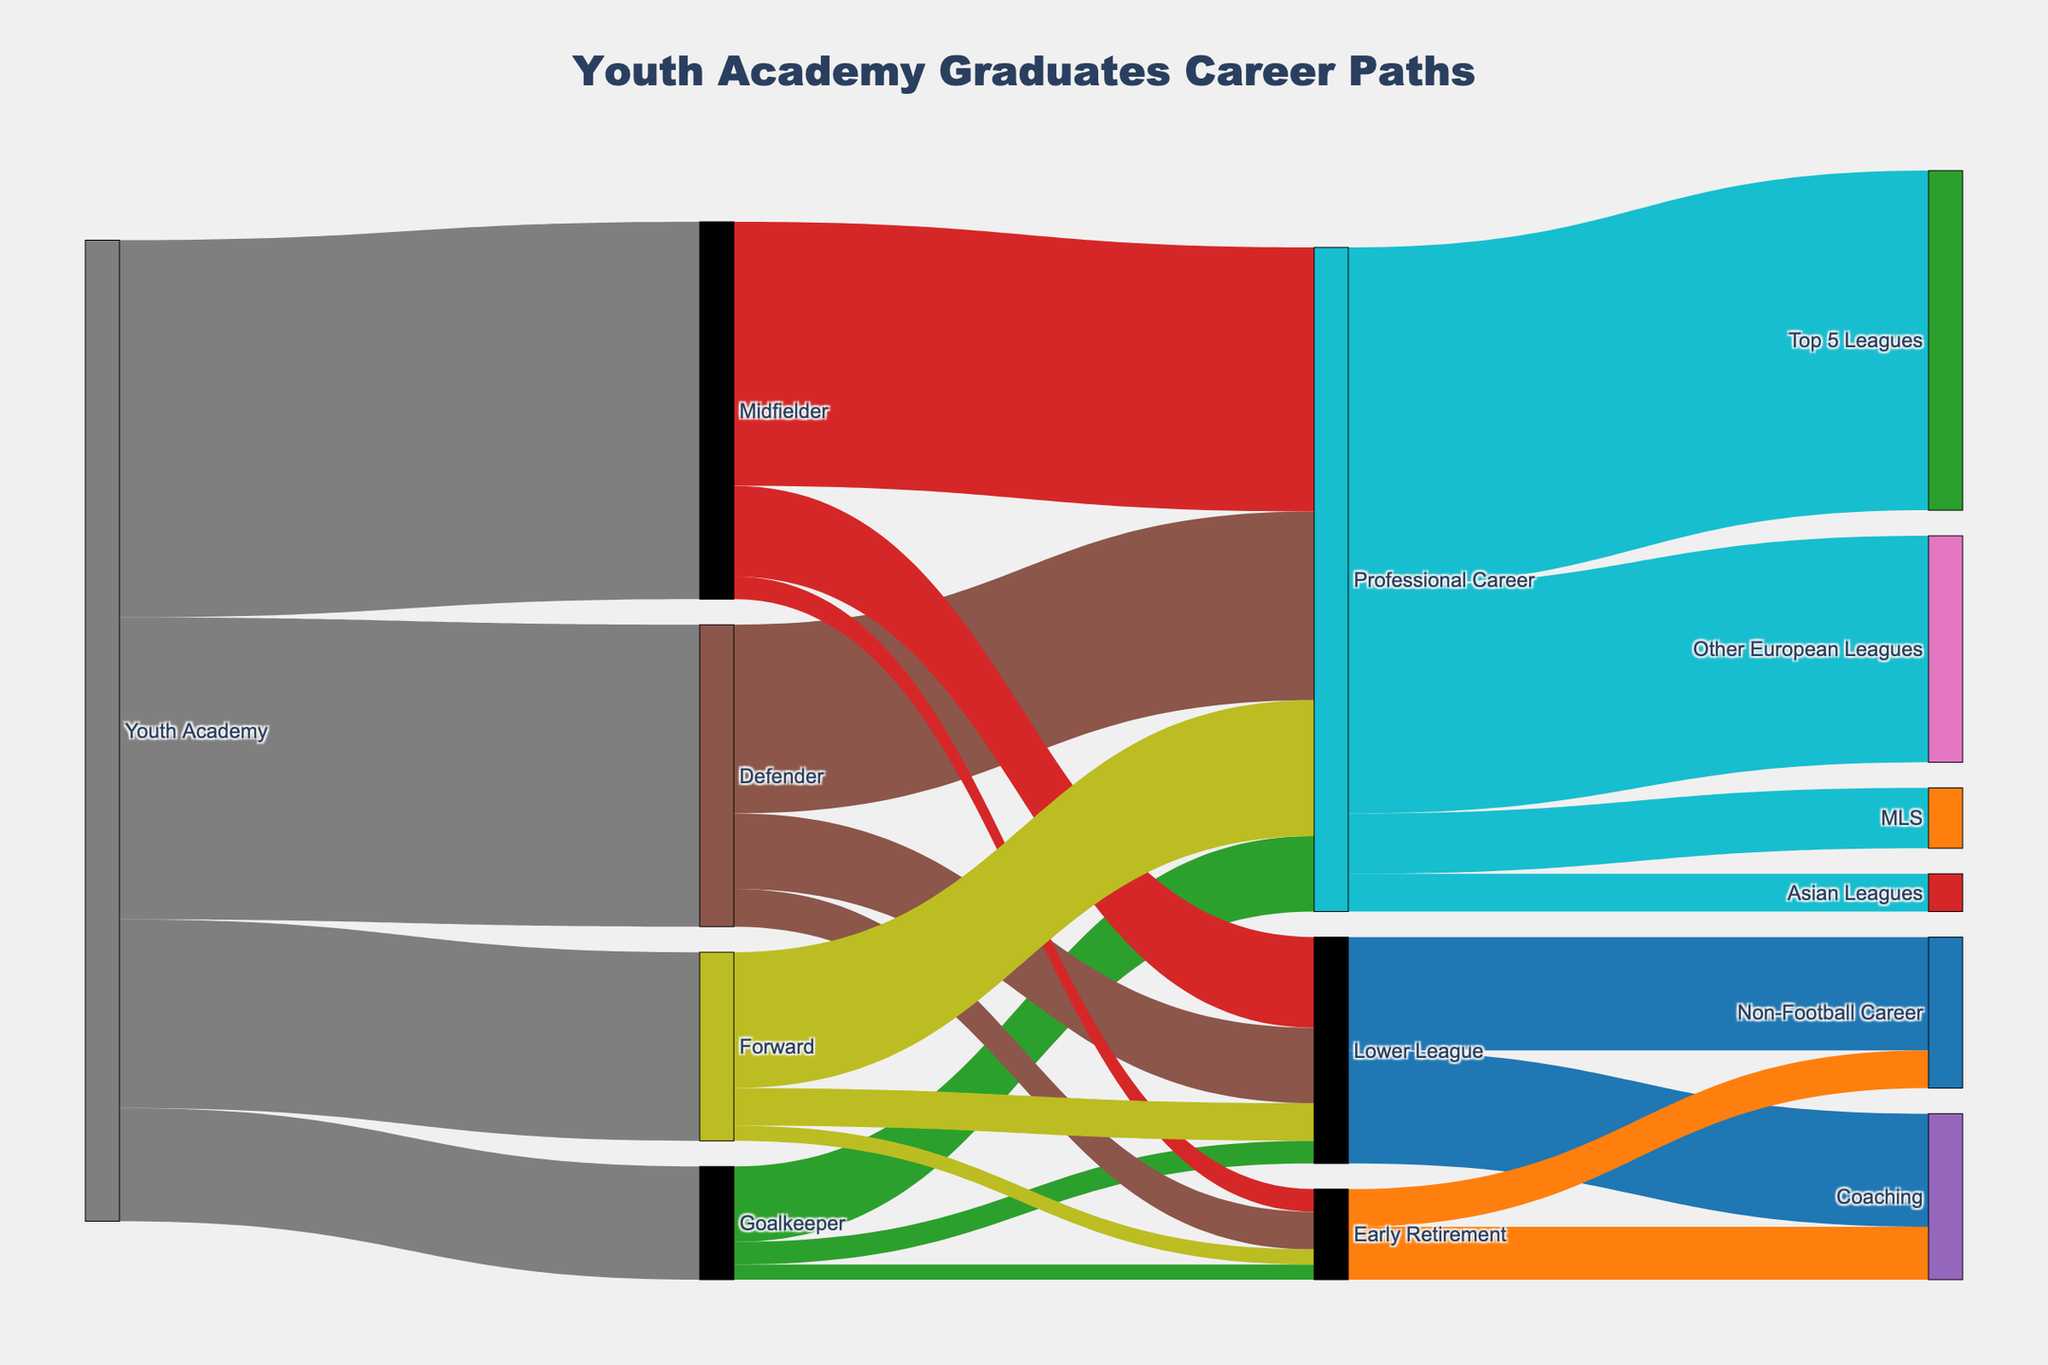What's the most common career path for youth academy graduates who become professional players? Check the Sankey diagram and follow the flow from "Professional Career" to its subsequent career paths. The "Top 5 Leagues" has the highest value, indicating it's the most common path.
Answer: Top 5 Leagues What percentage of youth academy graduates ended up playing as Midfielders? Summarize the values going from "Youth Academy" to each playing position and calculate the percentage for "Midfielder". It's (50 / 130) * 100.
Answer: 38.46% How many youth academy graduates who started as Defenders later chose Early Retirement? Track the flow from "Youth Academy" to "Defender" and further to "Early Retirement". The diagram shows it as 5.
Answer: 5 Which playing position has the least number of youth academy graduates progressing to a Professional Career? Follow the flow from each playing position to "Professional Career" and compare the values. "Goalkeeper" has the lowest number with 10.
Answer: Goalkeeper How many graduates who began as Forwards continued into Lower League careers? Look at the Sankey flow from "Forward" to "Lower League". The value is 5.
Answer: 5 What is the total number of youth academy graduates moving into coaching after Early Retirement and Lower League careers? Add the flows from "Early Retirement" to "Coaching" and "Lower League" to "Coaching." It is 7 + 15.
Answer: 22 Which career path has the least number of professional players after the initial "Professional Career" stage? Compare the flows from "Professional Career" to the subsequent career paths. "Asian Leagues" has the least with 5.
Answer: Asian Leagues If you sum the youth academy graduates who retired early as Goalkeepers, Midfielders, and Forwards, what is the total? Add the values of "Early Retirement" from these positions: 2 (Goalkeeper) + 3 (Midfielder) + 2 (Forward).
Answer: 7 What is the proportion of Professional Careers that transition into the MLS? Calculate the proportion using the values from "Professional Career" to "MLS" and the total professional careers: (8 / (45 + 30 + 8 + 5)).
Answer: 10% Between Lower League and Early Retirement categories, which contains more graduates pursuing Non-Football Careers? Compare the values: "Lower League" to "Non-Football Career" is 15, "Early Retirement" to "Non-Football Career" is 5.
Answer: Lower League 